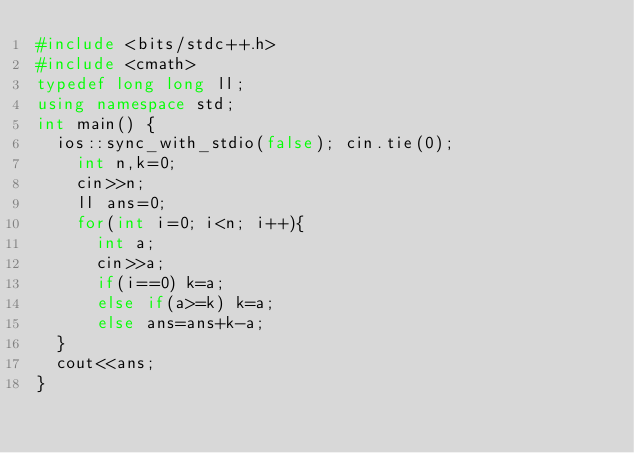Convert code to text. <code><loc_0><loc_0><loc_500><loc_500><_C++_>#include <bits/stdc++.h>
#include <cmath>
typedef long long ll;
using namespace std; 
int main() {
	ios::sync_with_stdio(false); cin.tie(0);
    int n,k=0;
    cin>>n;
    ll ans=0;
    for(int i=0; i<n; i++){
    	int a;
    	cin>>a;
    	if(i==0) k=a;
    	else if(a>=k) k=a;
    	else ans=ans+k-a;
	}
	cout<<ans;
}</code> 